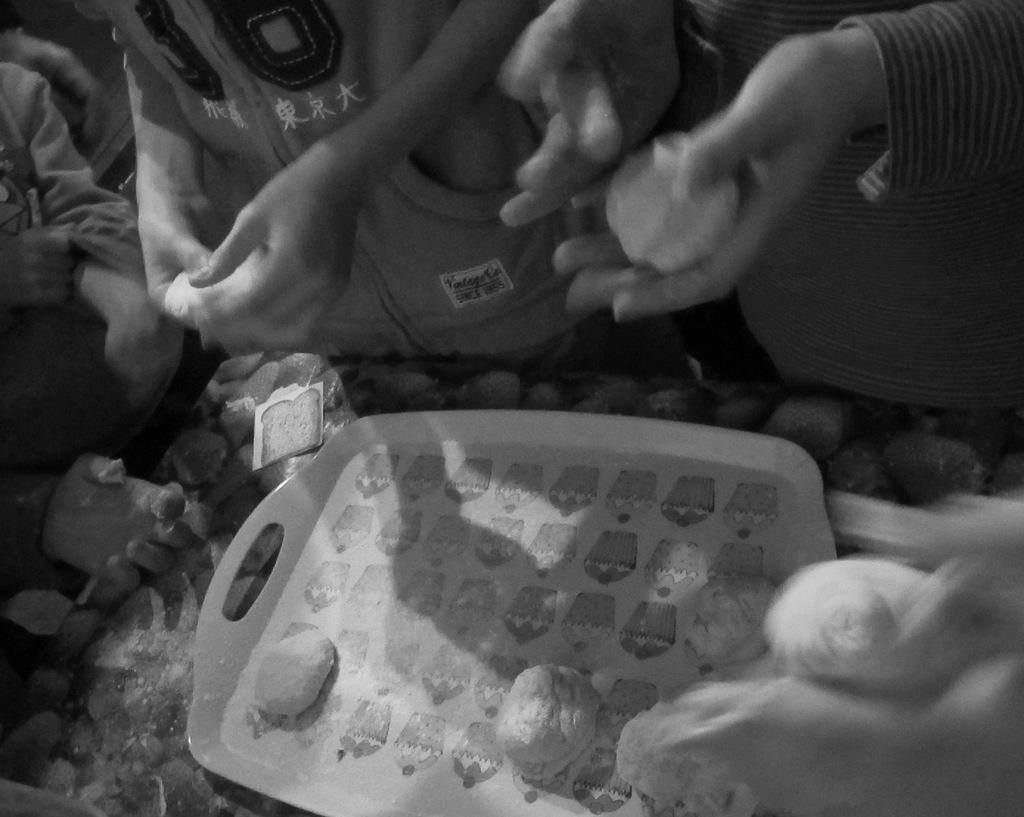Can you describe this image briefly? In this picture I can observe some food places in the tray. There are some people around the table. The tray is placed on the table. This is a black and white image. 